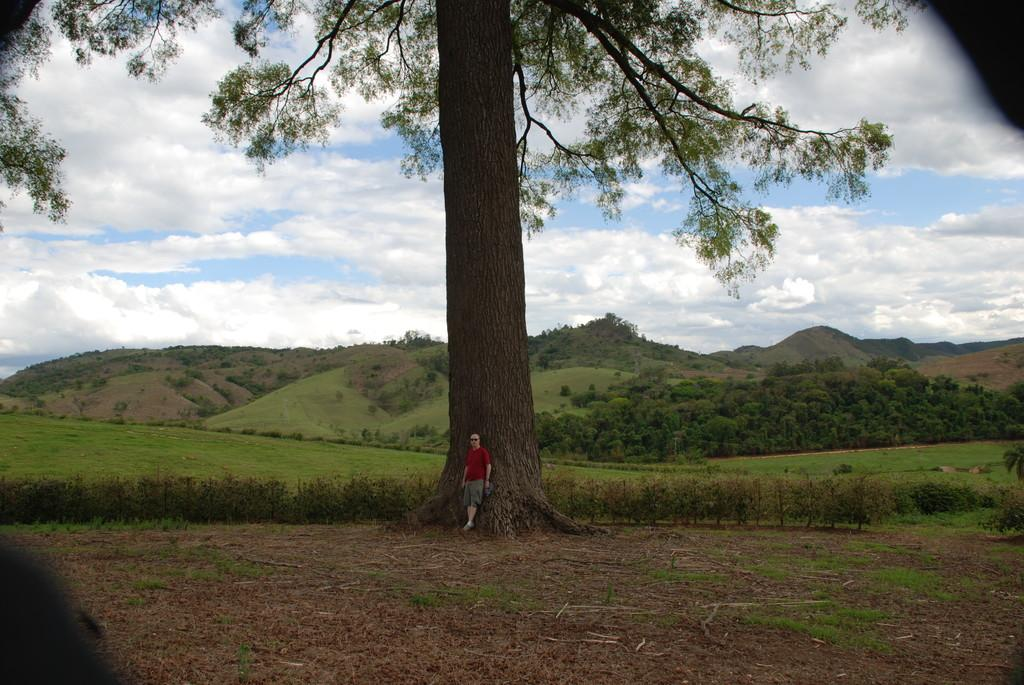Who or what is present in the image? There is a person in the image. What type of natural environment is depicted in the image? The image features trees, plants, grass, and mountains. What is the condition of the sky in the image? The sky is cloudy in the image. What type of oatmeal is being offered to the person in the image? There is no oatmeal present in the image, nor is anything being offered to the person. 